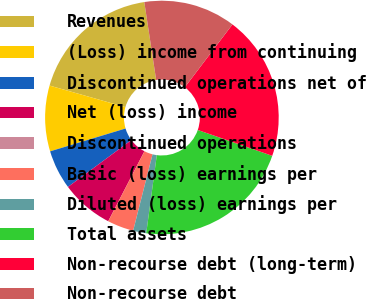Convert chart. <chart><loc_0><loc_0><loc_500><loc_500><pie_chart><fcel>Revenues<fcel>(Loss) income from continuing<fcel>Discontinued operations net of<fcel>Net (loss) income<fcel>Discontinued operations<fcel>Basic (loss) earnings per<fcel>Diluted (loss) earnings per<fcel>Total assets<fcel>Non-recourse debt (long-term)<fcel>Non-recourse debt<nl><fcel>18.18%<fcel>9.09%<fcel>5.45%<fcel>7.27%<fcel>0.0%<fcel>3.64%<fcel>1.82%<fcel>21.82%<fcel>20.0%<fcel>12.73%<nl></chart> 